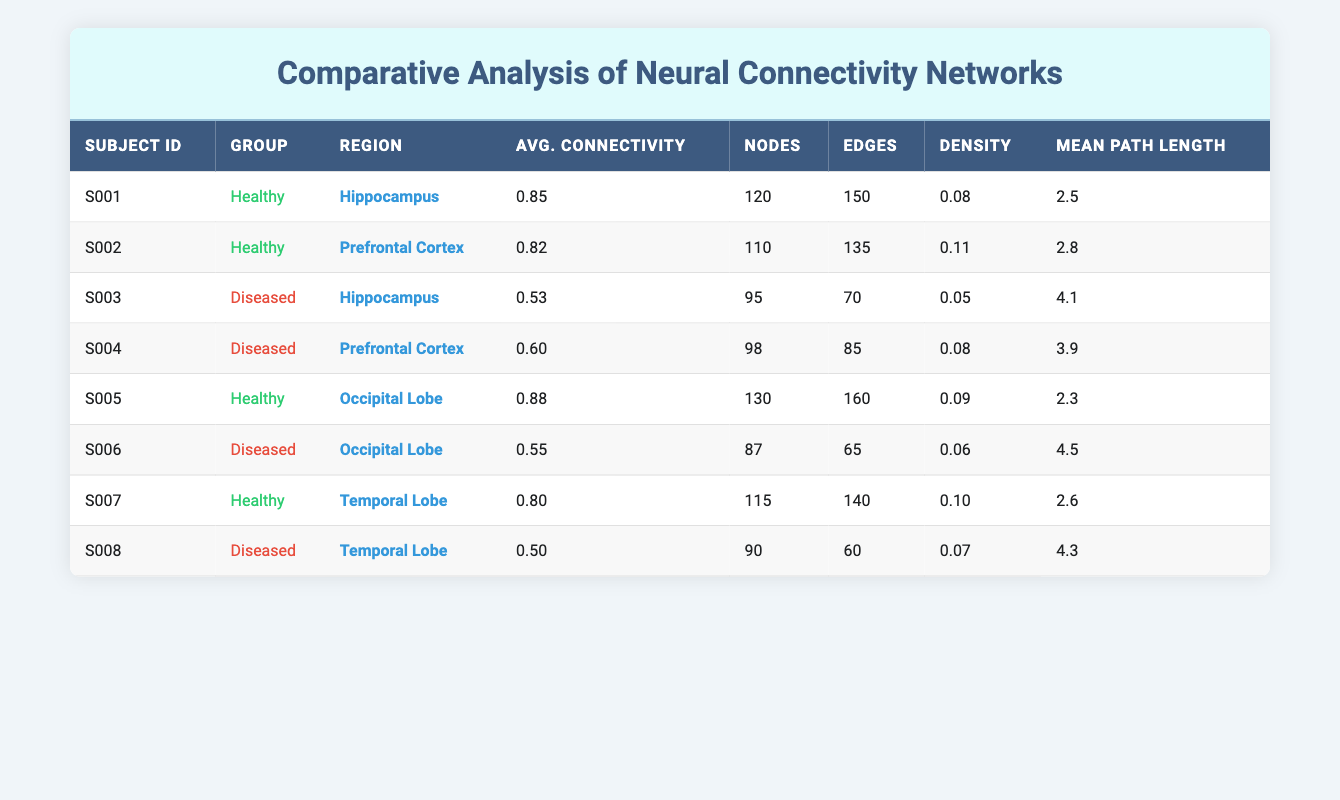What is the average connectivity of the Healthy group? To find the average connectivity for the Healthy group, sum the average connectivity values for subjects S001, S002, S005, and S007: (0.85 + 0.82 + 0.88 + 0.80) = 3.35. Then divide by the number of subjects in this group, which is 4: 3.35 / 4 = 0.8375.
Answer: 0.8375 What is the average path length for the Diseased group? The average path length for the Diseased group is calculated by summing the mean path lengths for subjects S003, S004, S006, and S008: (4.1 + 3.9 + 4.5 + 4.3) = 16.8. Dividing by the number of subjects, which is 4: 16.8 / 4 = 4.2.
Answer: 4.2 Which brain region has the highest average connectivity? By comparing the average connectivity values in the table, the highest average connectivity is 0.88 for the Occipital Lobe, noted in subject S005.
Answer: Occipital Lobe Are there more nodes in the Healthy group compared to the Diseased group? The total node count in the Healthy group is 120 + 110 + 130 + 115 = 475, while the Diseased group has 95 + 98 + 87 + 90 = 370. Since 475 > 370, there are indeed more nodes in the Healthy group.
Answer: Yes What is the density difference between the Healthy and Diseased groups based on their average density? The average density for the Healthy group is (0.08 + 0.11 + 0.09 + 0.10) / 4 = 0.095. The average density for the Diseased group is (0.05 + 0.08 + 0.06 + 0.07) / 4 = 0.065. The difference is 0.095 - 0.065 = 0.03.
Answer: 0.03 How many edges does the Hippocampus region have in total across both groups? Sum the edges for the Hippocampus region from both subjects: S001 (150) + S003 (70) = 220 edges in total.
Answer: 220 Is the average connectivity of the Temporal Lobe higher for Healthy subjects compared to Diseased subjects? For the Healthy group, the average connectivity in the Temporal Lobe (subject S007) is 0.80, while for the Diseased group (subject S008) it is 0.50. Since 0.80 > 0.50, the average connectivity is indeed higher in the Healthy group.
Answer: Yes Which group has the least mean path length on average? Calculate the average mean path length for both groups: Healthy average is (2.5 + 2.8 + 2.3 + 2.6) / 4 = 2.575 and Diseased average is (4.1 + 3.9 + 4.5 + 4.3) / 4 = 4.2. The Healthy group has the least mean path length.
Answer: Healthy What is the total number of edges in the Healthy group compared to the Diseased group? Total edges in the Healthy group is 150 + 135 + 160 + 140 = 585. For the Diseased group, it’s 70 + 85 + 65 + 60 = 280. Since 585 > 280, the Healthy group has more edges.
Answer: Yes 